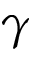<formula> <loc_0><loc_0><loc_500><loc_500>\gamma</formula> 